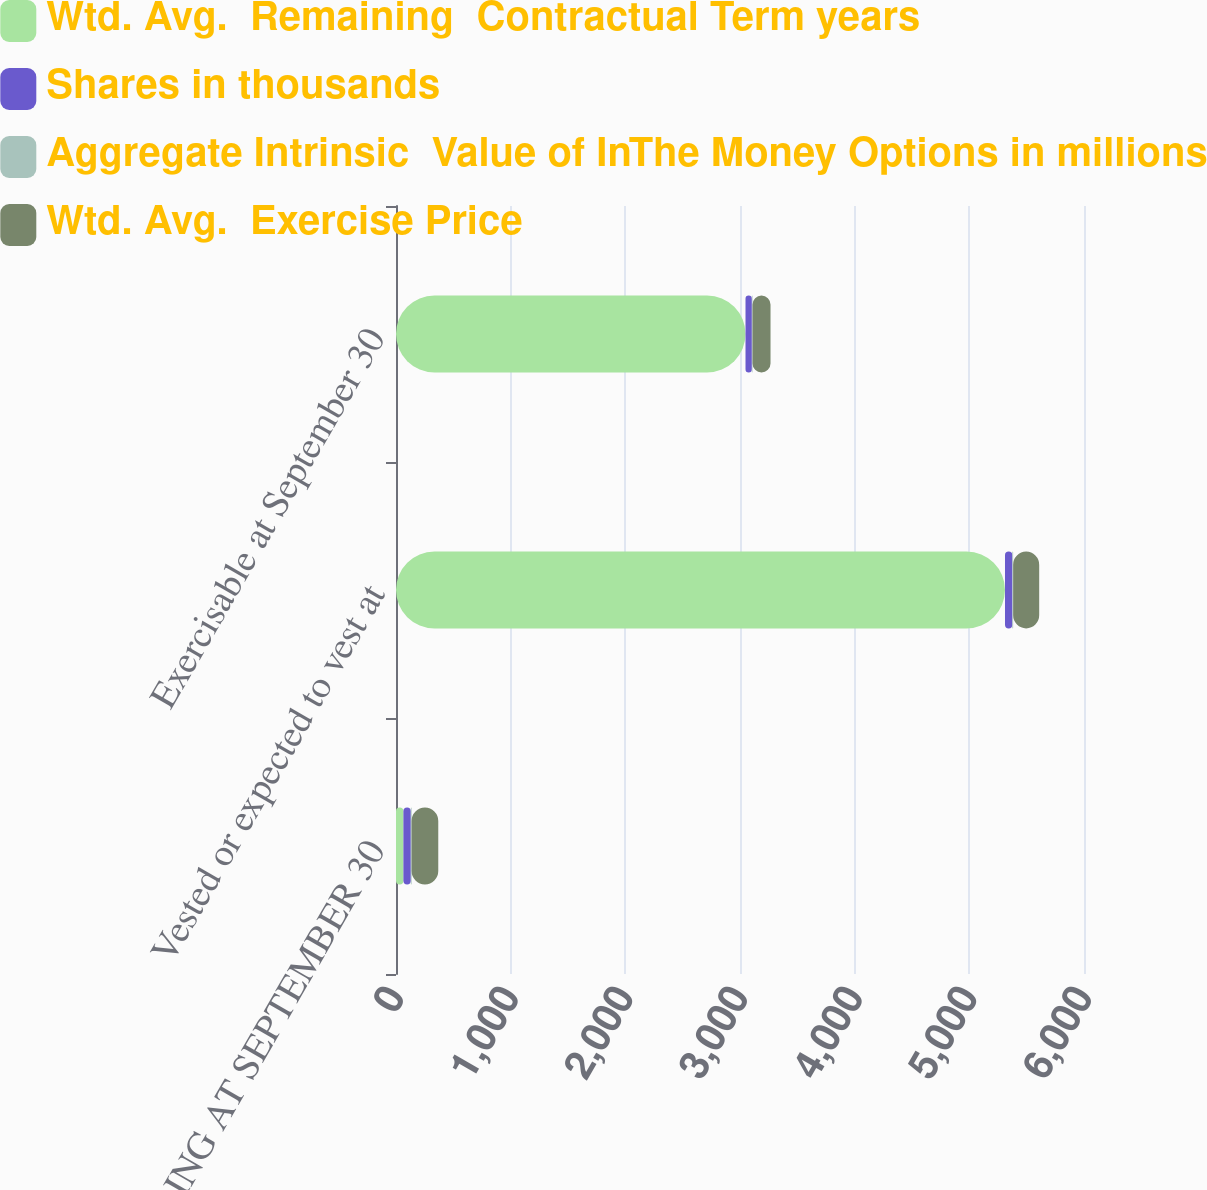Convert chart. <chart><loc_0><loc_0><loc_500><loc_500><stacked_bar_chart><ecel><fcel>OUTSTANDING AT SEPTEMBER 30<fcel>Vested or expected to vest at<fcel>Exercisable at September 30<nl><fcel>Wtd. Avg.  Remaining  Contractual Term years<fcel>64.53<fcel>5311<fcel>3048<nl><fcel>Shares in thousands<fcel>64.53<fcel>64.15<fcel>55.4<nl><fcel>Aggregate Intrinsic  Value of InThe Money Options in millions<fcel>6.9<fcel>6.8<fcel>5.6<nl><fcel>Wtd. Avg.  Exercise Price<fcel>232.7<fcel>227.3<fcel>157.1<nl></chart> 